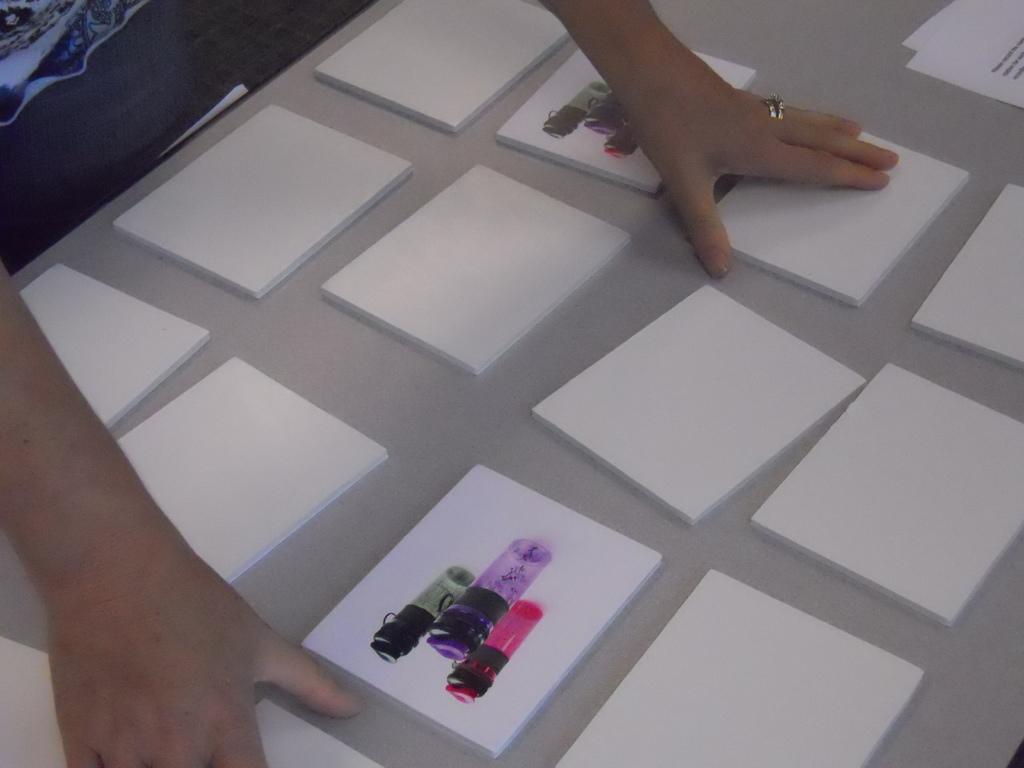Please provide a concise description of this image. In the image we can see there is a person and there are paper cardboards kept on the table. There is a picture of 3 bottles on the 2 paper cardboards. 